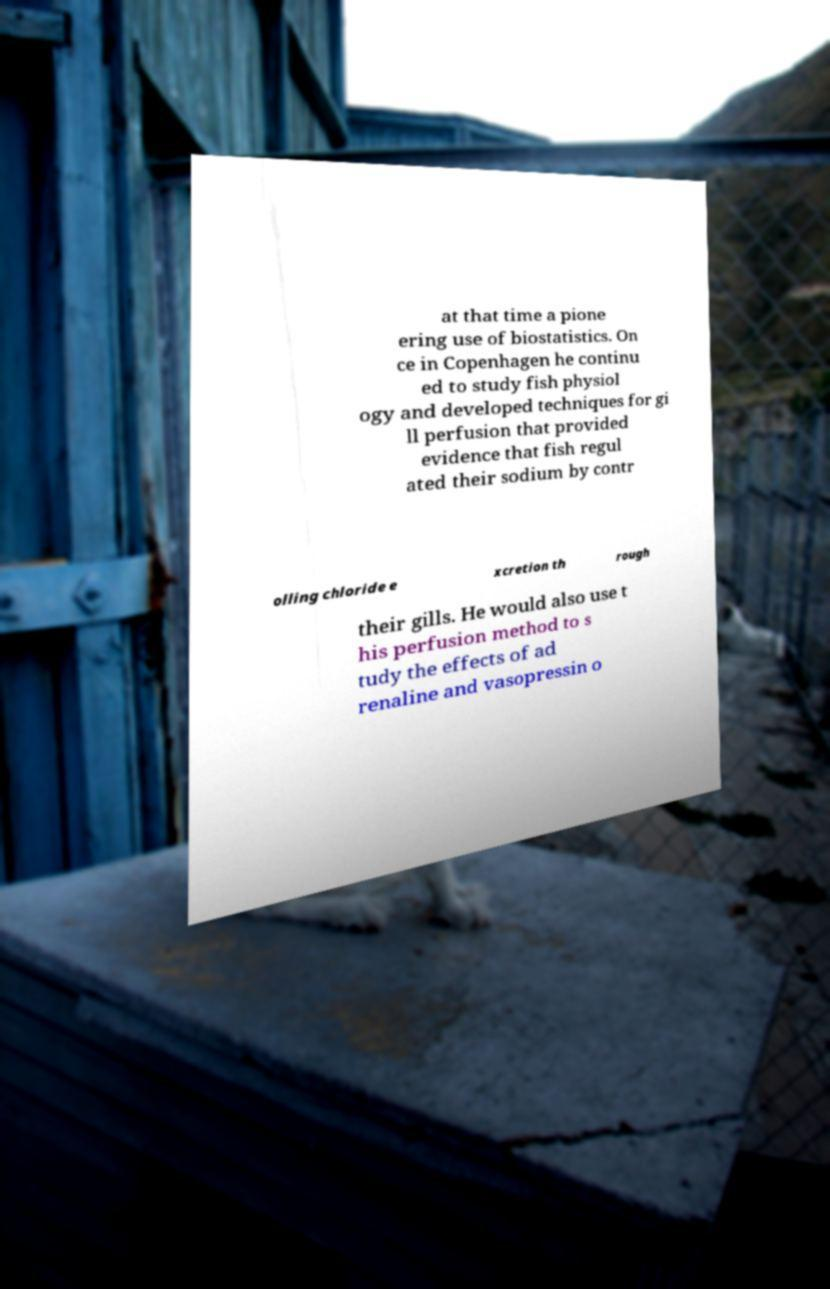Can you read and provide the text displayed in the image?This photo seems to have some interesting text. Can you extract and type it out for me? at that time a pione ering use of biostatistics. On ce in Copenhagen he continu ed to study fish physiol ogy and developed techniques for gi ll perfusion that provided evidence that fish regul ated their sodium by contr olling chloride e xcretion th rough their gills. He would also use t his perfusion method to s tudy the effects of ad renaline and vasopressin o 